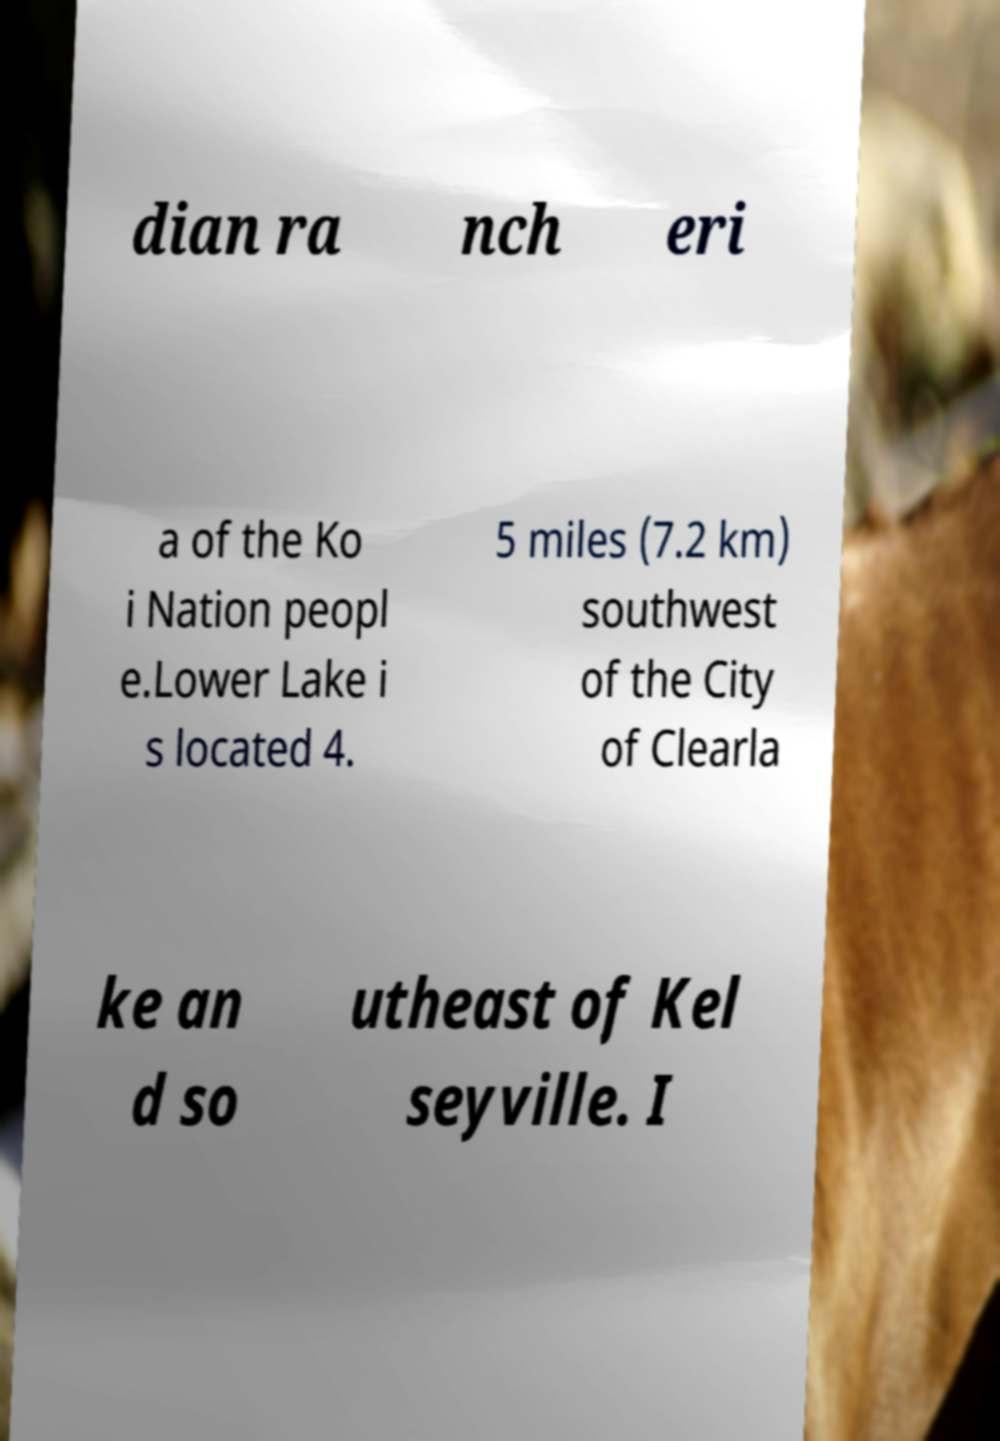Please read and relay the text visible in this image. What does it say? dian ra nch eri a of the Ko i Nation peopl e.Lower Lake i s located 4. 5 miles (7.2 km) southwest of the City of Clearla ke an d so utheast of Kel seyville. I 